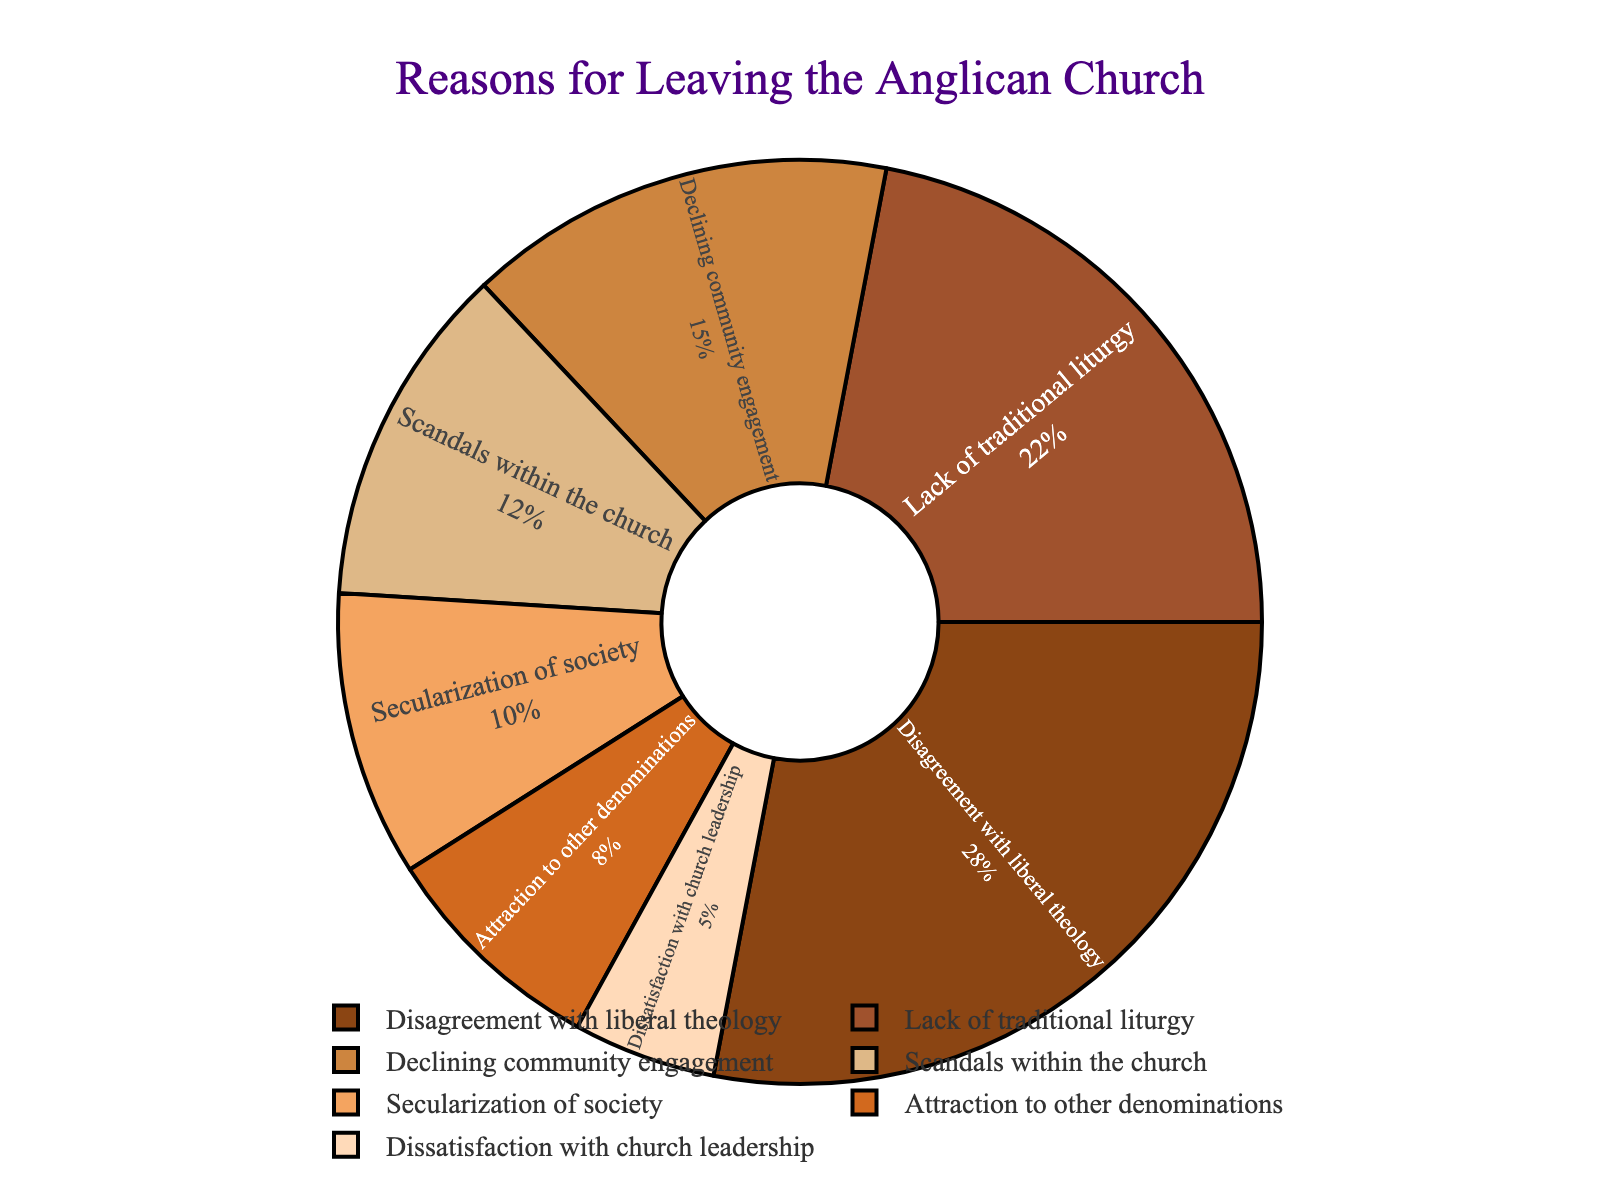What reason accounts for the highest percentage of people leaving the Anglican Church? According to the chart, the segment with the largest percentage represents “Disagreement with liberal theology” at 28%.
Answer: Disagreement with liberal theology Which categories have a percentage above 20%? By examining the pie chart, the two categories with percentages above 20% are “Disagreement with liberal theology” at 28% and “Lack of traditional liturgy” at 22%.
Answer: Disagreement with liberal theology and Lack of traditional liturgy How much more do “Disagreement with liberal theology” account for compared to “Dissatisfaction with church leadership”? By looking at the chart, “Disagreement with liberal theology” is 28%, while “Dissatisfaction with church leadership” is 5%. The difference is 28% - 5% = 23%.
Answer: 23% What's the total percentage of people who cited reasons related to theological or liturgical preferences? To find the total percentage, combine the percentages for “Disagreement with liberal theology” (28%) and “Lack of traditional liturgy” (22%). The sum is 28% + 22% = 50%.
Answer: 50% Is the percentage of people citing “Scandals within the church” greater than those citing “Attraction to other denominations”? The chart shows “Scandals within the church” at 12% and “Attraction to other denominations” at 8%. Since 12% is greater than 8%, the answer is yes.
Answer: Yes Which reason is represented by the color brown? OBSERVING THE COLOR distribution, the segment colored brown corresponds to “Disagreement with liberal theology” at 28%.
Answer: Disagreement with liberal theology Are there more people leaving due to “Secularization of society” or due to “Declining community engagement”? “Secularization of society” accounts for 10%, while “Declining community engagement” is at 15%. Therefore, more people leave due to “Declining community engagement”.
Answer: Declining community engagement Calculate the combined percentage for leaving reasons related to societal influences. To find the combined percentage, sum the percentages for “Secularization of society” (10%) and “Scandals within the church” (12%). The total is 10% + 12% = 22%.
Answer: 22% What is the sum of the percentages for all categories with less than 10%? The categories are “Attraction to other denominations” (8%) and “Dissatisfaction with church leadership” (5%). Summing these, we get 8% + 5% = 13%.
Answer: 13% How many categories have lower percentages than “Declining community engagement”? According to the pie chart, “Declining community engagement” is 15%. Categories with lower percentages are “Scandals within the church” (12%), “Secularization of society” (10%), “Attraction to other denominations” (8%), and “Dissatisfaction with church leadership” (5%). There are 4 such categories.
Answer: 4 